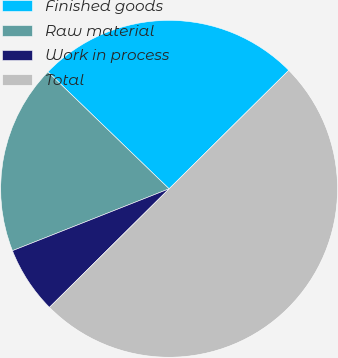Convert chart to OTSL. <chart><loc_0><loc_0><loc_500><loc_500><pie_chart><fcel>Finished goods<fcel>Raw material<fcel>Work in process<fcel>Total<nl><fcel>25.36%<fcel>18.21%<fcel>6.44%<fcel>50.0%<nl></chart> 